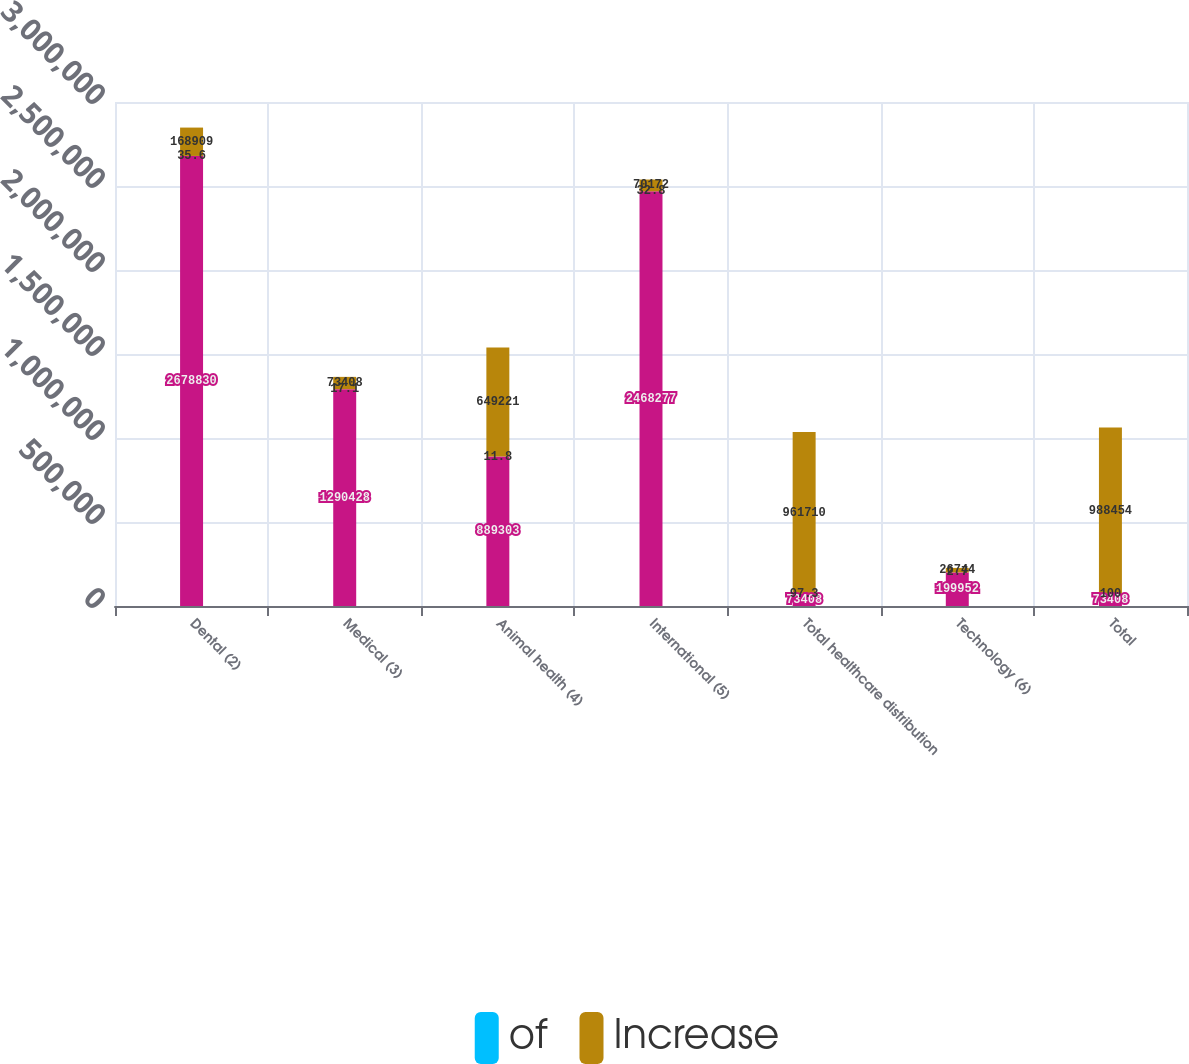<chart> <loc_0><loc_0><loc_500><loc_500><stacked_bar_chart><ecel><fcel>Dental (2)<fcel>Medical (3)<fcel>Animal health (4)<fcel>International (5)<fcel>Total healthcare distribution<fcel>Technology (6)<fcel>Total<nl><fcel>nan<fcel>2.67883e+06<fcel>1.29043e+06<fcel>889303<fcel>2.46828e+06<fcel>73408<fcel>199952<fcel>73408<nl><fcel>of<fcel>35.6<fcel>17.1<fcel>11.8<fcel>32.8<fcel>97.3<fcel>2.7<fcel>100<nl><fcel>Increase<fcel>168909<fcel>73408<fcel>649221<fcel>70172<fcel>961710<fcel>26744<fcel>988454<nl></chart> 